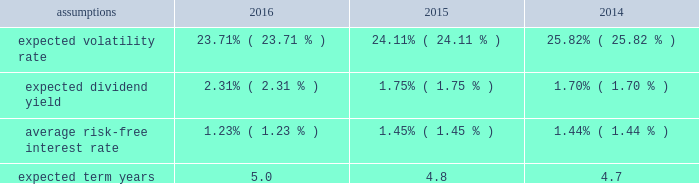Notes to the audited consolidated financial statements director stock compensation subplan eastman's 2016 director stock compensation subplan ( "directors' subplan" ) , a component of the 2012 omnibus plan , remains in effect until terminated by the board of directors or the earlier termination of thf e 2012 omnibus plan .
The directors' subplan provides for structured awards of restricted shares to non-employee members of the board of directors .
Restricted shares awarded under the directors' subplan are subject to the same terms and conditions of the 2012 omnibus plan .
The directors' subplan does not constitute a separate source of shares for grant of equity awards and all shares awarded are part of the 10 million shares authorized under the 2012 omnibus plan .
Shares of restricted stock are granted on the first day of a non-f employee director's initial term of service and shares of restricted stock are granted each year to each non-employee director on the date of the annual meeting of stockholders .
General the company is authorized by the board of directors under the 2012 omnibus plan tof provide awards to employees and non- employee members of the board of directors .
It has been the company's practice to issue new shares rather than treasury shares for equity awards that require settlement by the issuance of common stock and to withhold or accept back shares awarded to cover the related income tax obligations of employee participants .
Shares of unrestricted common stock owned by non-d employee directors are not eligible to be withheld or acquired to satisfy the withholding obligation related to their income taxes .
Aa shares of unrestricted common stock owned by specified senior management level employees are accepted by the company to pay the exercise price of stock options in accordance with the terms and conditions of their awards .
For 2016 , 2015 , and 2014 , total share-based compensation expense ( before tax ) of approximately $ 36 million , $ 36 million , and $ 28 million , respectively , was recognized in selling , general and administrative exd pense in the consolidated statements of earnings , comprehensive income and retained earnings for all share-based awards of which approximately $ 7 million , $ 7 million , and $ 4 million , respectively , related to stock options .
The compensation expense is recognized over the substantive vesting period , which may be a shorter time period than the stated vesting period for qualifying termination eligible employees as defined in the forms of award notice .
For 2016 , 2015 , and 2014 , approximately $ 2 million , $ 2 million , and $ 1 million , respectively , of stock option compensation expense was recognized due to qualifying termination eligibility preceding the requisite vesting period .
Stock option awards options have been granted on an annual basis to non-employee directors under the directors' subplan and predecessor plans and by the compensation and management development committee of the board of directors under the 2012 omnibus plan and predecessor plans to employees .
Option awards have an exercise price equal to the closing price of the company's stock on the date of grant .
The term of options is 10 years with vesting periods thf at vary up to three years .
Vesting usually occurs ratably over the vesting period or at the end of the vesting period .
The company utilizes the black scholes merton option valuation model which relies on certain assumptions to estimate an option's fair value .
The weighted average assumptions used in the determination of fair value for stock options awarded in 2016 , 2015 , and 2014 are provided in the table below: .

What percent of the total share-based compensation expense in 2016 was related to stock options? 
Computations: (7 / 36)
Answer: 0.19444. 